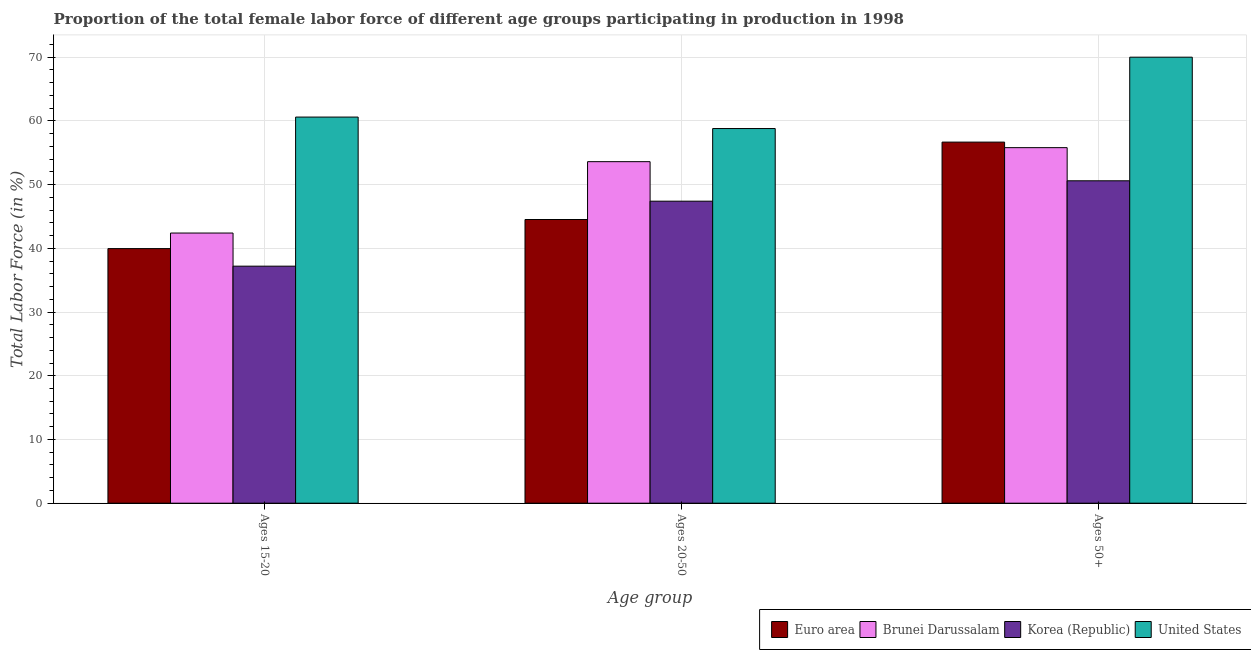How many different coloured bars are there?
Ensure brevity in your answer.  4. How many bars are there on the 2nd tick from the left?
Your response must be concise. 4. How many bars are there on the 2nd tick from the right?
Make the answer very short. 4. What is the label of the 1st group of bars from the left?
Provide a short and direct response. Ages 15-20. What is the percentage of female labor force within the age group 20-50 in United States?
Give a very brief answer. 58.8. Across all countries, what is the maximum percentage of female labor force above age 50?
Offer a very short reply. 70. Across all countries, what is the minimum percentage of female labor force within the age group 15-20?
Offer a terse response. 37.2. What is the total percentage of female labor force within the age group 20-50 in the graph?
Make the answer very short. 204.32. What is the difference between the percentage of female labor force within the age group 15-20 in Korea (Republic) and that in Euro area?
Ensure brevity in your answer.  -2.76. What is the difference between the percentage of female labor force within the age group 20-50 in Euro area and the percentage of female labor force within the age group 15-20 in Brunei Darussalam?
Provide a succinct answer. 2.12. What is the average percentage of female labor force within the age group 20-50 per country?
Give a very brief answer. 51.08. What is the difference between the percentage of female labor force above age 50 and percentage of female labor force within the age group 20-50 in Brunei Darussalam?
Your response must be concise. 2.2. In how many countries, is the percentage of female labor force above age 50 greater than 34 %?
Offer a very short reply. 4. What is the ratio of the percentage of female labor force within the age group 20-50 in Brunei Darussalam to that in Euro area?
Ensure brevity in your answer.  1.2. Is the difference between the percentage of female labor force within the age group 20-50 in Euro area and United States greater than the difference between the percentage of female labor force above age 50 in Euro area and United States?
Provide a short and direct response. No. What is the difference between the highest and the second highest percentage of female labor force within the age group 20-50?
Offer a very short reply. 5.2. What is the difference between the highest and the lowest percentage of female labor force above age 50?
Give a very brief answer. 19.4. What does the 2nd bar from the left in Ages 50+ represents?
Provide a short and direct response. Brunei Darussalam. Is it the case that in every country, the sum of the percentage of female labor force within the age group 15-20 and percentage of female labor force within the age group 20-50 is greater than the percentage of female labor force above age 50?
Your answer should be very brief. Yes. How many countries are there in the graph?
Your answer should be compact. 4. What is the difference between two consecutive major ticks on the Y-axis?
Provide a succinct answer. 10. How are the legend labels stacked?
Make the answer very short. Horizontal. What is the title of the graph?
Your response must be concise. Proportion of the total female labor force of different age groups participating in production in 1998. What is the label or title of the X-axis?
Your response must be concise. Age group. What is the label or title of the Y-axis?
Give a very brief answer. Total Labor Force (in %). What is the Total Labor Force (in %) of Euro area in Ages 15-20?
Make the answer very short. 39.96. What is the Total Labor Force (in %) in Brunei Darussalam in Ages 15-20?
Make the answer very short. 42.4. What is the Total Labor Force (in %) in Korea (Republic) in Ages 15-20?
Offer a very short reply. 37.2. What is the Total Labor Force (in %) of United States in Ages 15-20?
Offer a terse response. 60.6. What is the Total Labor Force (in %) in Euro area in Ages 20-50?
Keep it short and to the point. 44.52. What is the Total Labor Force (in %) of Brunei Darussalam in Ages 20-50?
Your answer should be very brief. 53.6. What is the Total Labor Force (in %) of Korea (Republic) in Ages 20-50?
Ensure brevity in your answer.  47.4. What is the Total Labor Force (in %) in United States in Ages 20-50?
Offer a very short reply. 58.8. What is the Total Labor Force (in %) in Euro area in Ages 50+?
Offer a terse response. 56.67. What is the Total Labor Force (in %) in Brunei Darussalam in Ages 50+?
Offer a very short reply. 55.8. What is the Total Labor Force (in %) in Korea (Republic) in Ages 50+?
Provide a short and direct response. 50.6. Across all Age group, what is the maximum Total Labor Force (in %) of Euro area?
Give a very brief answer. 56.67. Across all Age group, what is the maximum Total Labor Force (in %) in Brunei Darussalam?
Make the answer very short. 55.8. Across all Age group, what is the maximum Total Labor Force (in %) of Korea (Republic)?
Your answer should be very brief. 50.6. Across all Age group, what is the minimum Total Labor Force (in %) of Euro area?
Offer a very short reply. 39.96. Across all Age group, what is the minimum Total Labor Force (in %) of Brunei Darussalam?
Give a very brief answer. 42.4. Across all Age group, what is the minimum Total Labor Force (in %) of Korea (Republic)?
Offer a terse response. 37.2. Across all Age group, what is the minimum Total Labor Force (in %) in United States?
Your answer should be very brief. 58.8. What is the total Total Labor Force (in %) of Euro area in the graph?
Make the answer very short. 141.15. What is the total Total Labor Force (in %) in Brunei Darussalam in the graph?
Your response must be concise. 151.8. What is the total Total Labor Force (in %) in Korea (Republic) in the graph?
Give a very brief answer. 135.2. What is the total Total Labor Force (in %) in United States in the graph?
Provide a short and direct response. 189.4. What is the difference between the Total Labor Force (in %) in Euro area in Ages 15-20 and that in Ages 20-50?
Keep it short and to the point. -4.57. What is the difference between the Total Labor Force (in %) in Brunei Darussalam in Ages 15-20 and that in Ages 20-50?
Provide a succinct answer. -11.2. What is the difference between the Total Labor Force (in %) of Korea (Republic) in Ages 15-20 and that in Ages 20-50?
Give a very brief answer. -10.2. What is the difference between the Total Labor Force (in %) of Euro area in Ages 15-20 and that in Ages 50+?
Your response must be concise. -16.71. What is the difference between the Total Labor Force (in %) of Euro area in Ages 20-50 and that in Ages 50+?
Give a very brief answer. -12.15. What is the difference between the Total Labor Force (in %) of Korea (Republic) in Ages 20-50 and that in Ages 50+?
Your answer should be very brief. -3.2. What is the difference between the Total Labor Force (in %) in Euro area in Ages 15-20 and the Total Labor Force (in %) in Brunei Darussalam in Ages 20-50?
Your answer should be compact. -13.64. What is the difference between the Total Labor Force (in %) of Euro area in Ages 15-20 and the Total Labor Force (in %) of Korea (Republic) in Ages 20-50?
Provide a short and direct response. -7.44. What is the difference between the Total Labor Force (in %) of Euro area in Ages 15-20 and the Total Labor Force (in %) of United States in Ages 20-50?
Offer a very short reply. -18.84. What is the difference between the Total Labor Force (in %) in Brunei Darussalam in Ages 15-20 and the Total Labor Force (in %) in United States in Ages 20-50?
Provide a short and direct response. -16.4. What is the difference between the Total Labor Force (in %) in Korea (Republic) in Ages 15-20 and the Total Labor Force (in %) in United States in Ages 20-50?
Ensure brevity in your answer.  -21.6. What is the difference between the Total Labor Force (in %) in Euro area in Ages 15-20 and the Total Labor Force (in %) in Brunei Darussalam in Ages 50+?
Your response must be concise. -15.84. What is the difference between the Total Labor Force (in %) of Euro area in Ages 15-20 and the Total Labor Force (in %) of Korea (Republic) in Ages 50+?
Your answer should be compact. -10.64. What is the difference between the Total Labor Force (in %) in Euro area in Ages 15-20 and the Total Labor Force (in %) in United States in Ages 50+?
Your answer should be compact. -30.04. What is the difference between the Total Labor Force (in %) in Brunei Darussalam in Ages 15-20 and the Total Labor Force (in %) in Korea (Republic) in Ages 50+?
Provide a succinct answer. -8.2. What is the difference between the Total Labor Force (in %) in Brunei Darussalam in Ages 15-20 and the Total Labor Force (in %) in United States in Ages 50+?
Keep it short and to the point. -27.6. What is the difference between the Total Labor Force (in %) in Korea (Republic) in Ages 15-20 and the Total Labor Force (in %) in United States in Ages 50+?
Offer a very short reply. -32.8. What is the difference between the Total Labor Force (in %) of Euro area in Ages 20-50 and the Total Labor Force (in %) of Brunei Darussalam in Ages 50+?
Keep it short and to the point. -11.28. What is the difference between the Total Labor Force (in %) in Euro area in Ages 20-50 and the Total Labor Force (in %) in Korea (Republic) in Ages 50+?
Offer a terse response. -6.08. What is the difference between the Total Labor Force (in %) of Euro area in Ages 20-50 and the Total Labor Force (in %) of United States in Ages 50+?
Give a very brief answer. -25.48. What is the difference between the Total Labor Force (in %) in Brunei Darussalam in Ages 20-50 and the Total Labor Force (in %) in Korea (Republic) in Ages 50+?
Make the answer very short. 3. What is the difference between the Total Labor Force (in %) in Brunei Darussalam in Ages 20-50 and the Total Labor Force (in %) in United States in Ages 50+?
Give a very brief answer. -16.4. What is the difference between the Total Labor Force (in %) of Korea (Republic) in Ages 20-50 and the Total Labor Force (in %) of United States in Ages 50+?
Give a very brief answer. -22.6. What is the average Total Labor Force (in %) of Euro area per Age group?
Your answer should be very brief. 47.05. What is the average Total Labor Force (in %) of Brunei Darussalam per Age group?
Offer a very short reply. 50.6. What is the average Total Labor Force (in %) of Korea (Republic) per Age group?
Make the answer very short. 45.07. What is the average Total Labor Force (in %) of United States per Age group?
Your response must be concise. 63.13. What is the difference between the Total Labor Force (in %) in Euro area and Total Labor Force (in %) in Brunei Darussalam in Ages 15-20?
Provide a succinct answer. -2.44. What is the difference between the Total Labor Force (in %) in Euro area and Total Labor Force (in %) in Korea (Republic) in Ages 15-20?
Keep it short and to the point. 2.76. What is the difference between the Total Labor Force (in %) in Euro area and Total Labor Force (in %) in United States in Ages 15-20?
Give a very brief answer. -20.64. What is the difference between the Total Labor Force (in %) of Brunei Darussalam and Total Labor Force (in %) of Korea (Republic) in Ages 15-20?
Give a very brief answer. 5.2. What is the difference between the Total Labor Force (in %) in Brunei Darussalam and Total Labor Force (in %) in United States in Ages 15-20?
Provide a succinct answer. -18.2. What is the difference between the Total Labor Force (in %) of Korea (Republic) and Total Labor Force (in %) of United States in Ages 15-20?
Ensure brevity in your answer.  -23.4. What is the difference between the Total Labor Force (in %) in Euro area and Total Labor Force (in %) in Brunei Darussalam in Ages 20-50?
Your response must be concise. -9.08. What is the difference between the Total Labor Force (in %) of Euro area and Total Labor Force (in %) of Korea (Republic) in Ages 20-50?
Offer a very short reply. -2.88. What is the difference between the Total Labor Force (in %) of Euro area and Total Labor Force (in %) of United States in Ages 20-50?
Provide a succinct answer. -14.28. What is the difference between the Total Labor Force (in %) of Brunei Darussalam and Total Labor Force (in %) of Korea (Republic) in Ages 20-50?
Your response must be concise. 6.2. What is the difference between the Total Labor Force (in %) of Korea (Republic) and Total Labor Force (in %) of United States in Ages 20-50?
Offer a very short reply. -11.4. What is the difference between the Total Labor Force (in %) in Euro area and Total Labor Force (in %) in Brunei Darussalam in Ages 50+?
Your response must be concise. 0.87. What is the difference between the Total Labor Force (in %) in Euro area and Total Labor Force (in %) in Korea (Republic) in Ages 50+?
Your response must be concise. 6.07. What is the difference between the Total Labor Force (in %) of Euro area and Total Labor Force (in %) of United States in Ages 50+?
Offer a terse response. -13.33. What is the difference between the Total Labor Force (in %) in Brunei Darussalam and Total Labor Force (in %) in United States in Ages 50+?
Provide a succinct answer. -14.2. What is the difference between the Total Labor Force (in %) of Korea (Republic) and Total Labor Force (in %) of United States in Ages 50+?
Keep it short and to the point. -19.4. What is the ratio of the Total Labor Force (in %) in Euro area in Ages 15-20 to that in Ages 20-50?
Ensure brevity in your answer.  0.9. What is the ratio of the Total Labor Force (in %) of Brunei Darussalam in Ages 15-20 to that in Ages 20-50?
Ensure brevity in your answer.  0.79. What is the ratio of the Total Labor Force (in %) in Korea (Republic) in Ages 15-20 to that in Ages 20-50?
Your answer should be compact. 0.78. What is the ratio of the Total Labor Force (in %) in United States in Ages 15-20 to that in Ages 20-50?
Your answer should be compact. 1.03. What is the ratio of the Total Labor Force (in %) of Euro area in Ages 15-20 to that in Ages 50+?
Keep it short and to the point. 0.71. What is the ratio of the Total Labor Force (in %) in Brunei Darussalam in Ages 15-20 to that in Ages 50+?
Provide a short and direct response. 0.76. What is the ratio of the Total Labor Force (in %) of Korea (Republic) in Ages 15-20 to that in Ages 50+?
Keep it short and to the point. 0.74. What is the ratio of the Total Labor Force (in %) in United States in Ages 15-20 to that in Ages 50+?
Give a very brief answer. 0.87. What is the ratio of the Total Labor Force (in %) of Euro area in Ages 20-50 to that in Ages 50+?
Your answer should be compact. 0.79. What is the ratio of the Total Labor Force (in %) in Brunei Darussalam in Ages 20-50 to that in Ages 50+?
Give a very brief answer. 0.96. What is the ratio of the Total Labor Force (in %) in Korea (Republic) in Ages 20-50 to that in Ages 50+?
Offer a terse response. 0.94. What is the ratio of the Total Labor Force (in %) in United States in Ages 20-50 to that in Ages 50+?
Provide a short and direct response. 0.84. What is the difference between the highest and the second highest Total Labor Force (in %) in Euro area?
Provide a short and direct response. 12.15. What is the difference between the highest and the second highest Total Labor Force (in %) in Brunei Darussalam?
Make the answer very short. 2.2. What is the difference between the highest and the second highest Total Labor Force (in %) in Korea (Republic)?
Ensure brevity in your answer.  3.2. What is the difference between the highest and the lowest Total Labor Force (in %) of Euro area?
Your answer should be very brief. 16.71. What is the difference between the highest and the lowest Total Labor Force (in %) of Korea (Republic)?
Your answer should be compact. 13.4. 